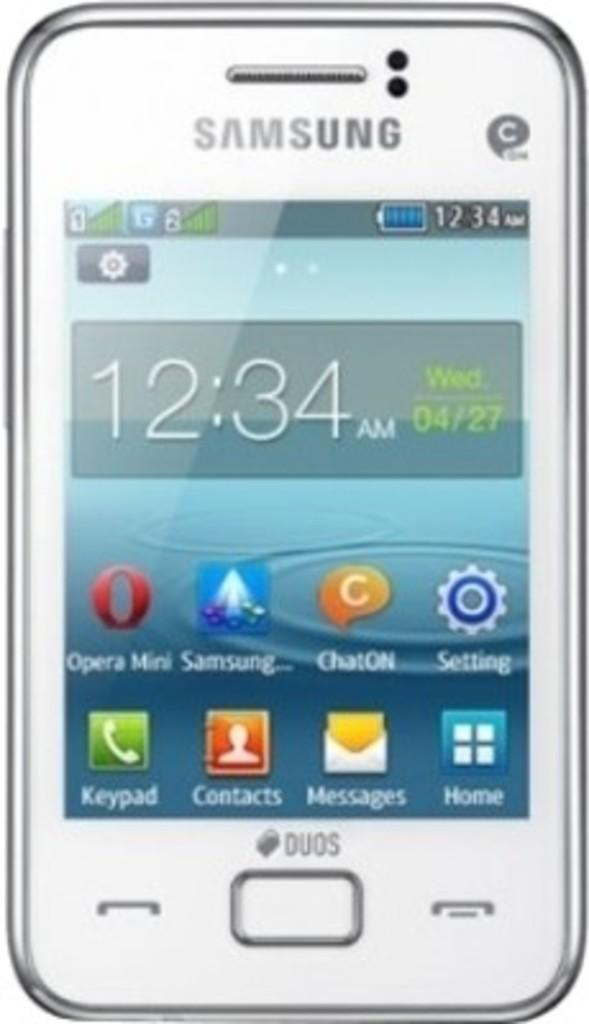<image>
Provide a brief description of the given image. White samsung phone that shows the home screen 